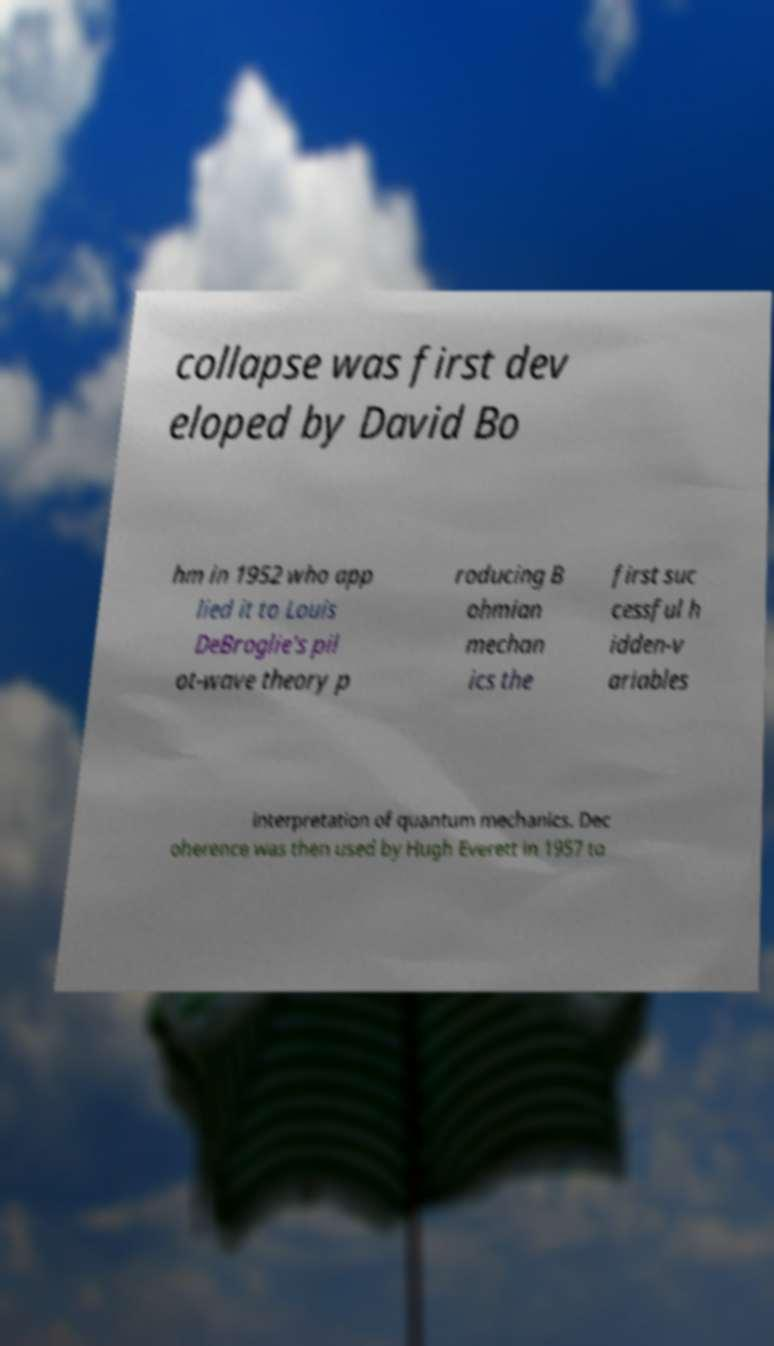Could you extract and type out the text from this image? collapse was first dev eloped by David Bo hm in 1952 who app lied it to Louis DeBroglie's pil ot-wave theory p roducing B ohmian mechan ics the first suc cessful h idden-v ariables interpretation of quantum mechanics. Dec oherence was then used by Hugh Everett in 1957 to 